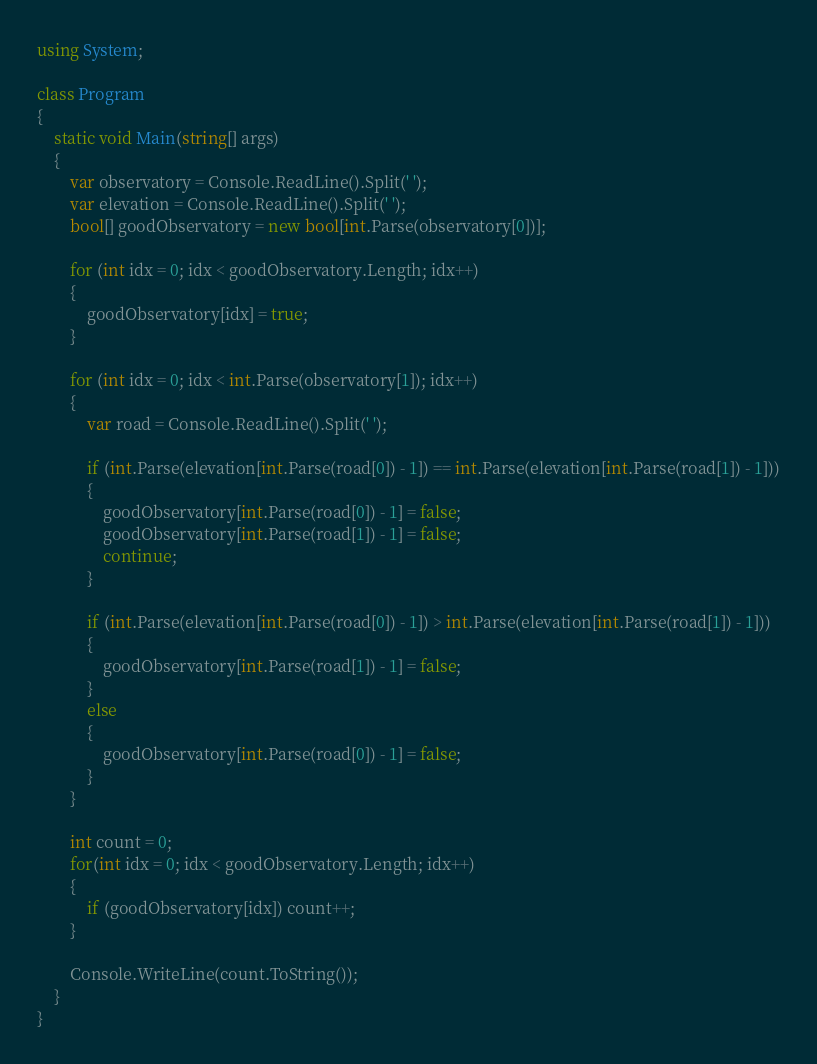<code> <loc_0><loc_0><loc_500><loc_500><_C#_>using System;

class Program
{
    static void Main(string[] args)
    {
        var observatory = Console.ReadLine().Split(' ');
        var elevation = Console.ReadLine().Split(' ');
        bool[] goodObservatory = new bool[int.Parse(observatory[0])];

        for (int idx = 0; idx < goodObservatory.Length; idx++)
        {
            goodObservatory[idx] = true;
        }

        for (int idx = 0; idx < int.Parse(observatory[1]); idx++)
        {
            var road = Console.ReadLine().Split(' ');

            if (int.Parse(elevation[int.Parse(road[0]) - 1]) == int.Parse(elevation[int.Parse(road[1]) - 1]))
            {
                goodObservatory[int.Parse(road[0]) - 1] = false;
                goodObservatory[int.Parse(road[1]) - 1] = false;
                continue;
            }

            if (int.Parse(elevation[int.Parse(road[0]) - 1]) > int.Parse(elevation[int.Parse(road[1]) - 1]))
            {
                goodObservatory[int.Parse(road[1]) - 1] = false;
            }
            else
            {
                goodObservatory[int.Parse(road[0]) - 1] = false;
            }
        }

        int count = 0;
        for(int idx = 0; idx < goodObservatory.Length; idx++)
        {
            if (goodObservatory[idx]) count++;
        }

        Console.WriteLine(count.ToString());
    }
}</code> 